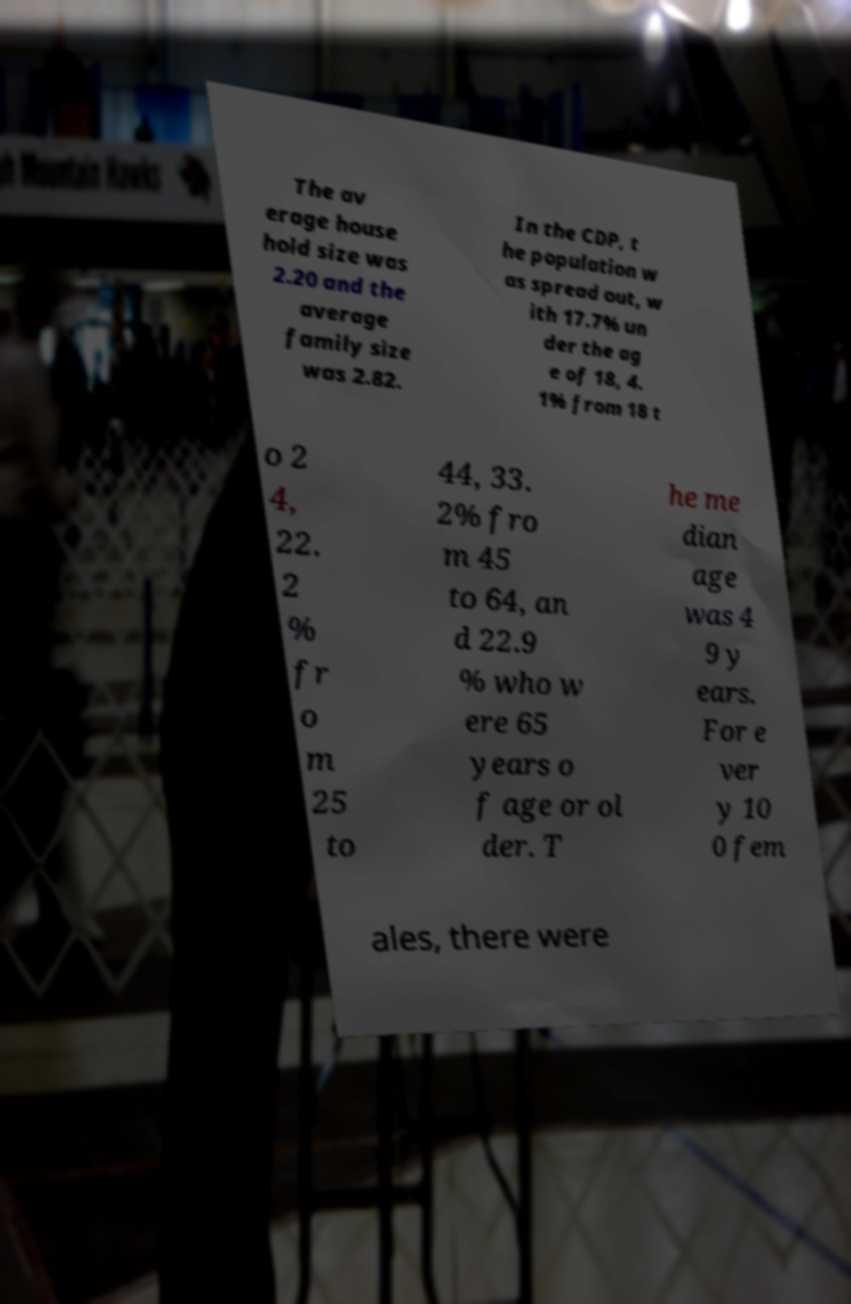Can you read and provide the text displayed in the image?This photo seems to have some interesting text. Can you extract and type it out for me? The av erage house hold size was 2.20 and the average family size was 2.82. In the CDP, t he population w as spread out, w ith 17.7% un der the ag e of 18, 4. 1% from 18 t o 2 4, 22. 2 % fr o m 25 to 44, 33. 2% fro m 45 to 64, an d 22.9 % who w ere 65 years o f age or ol der. T he me dian age was 4 9 y ears. For e ver y 10 0 fem ales, there were 